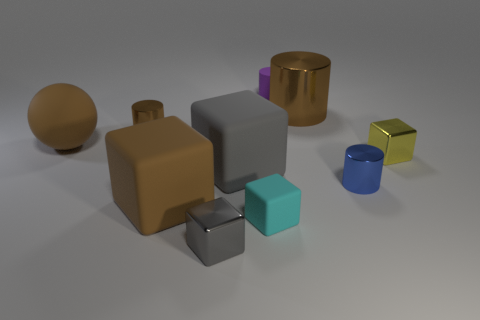What number of other things are made of the same material as the small gray block?
Keep it short and to the point. 4. There is a small rubber block; does it have the same color as the metal block to the right of the tiny gray shiny object?
Your answer should be very brief. No. Are there more big brown rubber balls that are on the left side of the matte cylinder than brown metallic cubes?
Ensure brevity in your answer.  Yes. There is a tiny shiny cylinder behind the tiny shiny cylinder that is in front of the ball; what number of small metal objects are to the left of it?
Offer a terse response. 0. Does the small object that is in front of the small cyan block have the same shape as the cyan thing?
Make the answer very short. Yes. There is a small gray cube in front of the tiny yellow metallic thing; what is it made of?
Your response must be concise. Metal. There is a shiny thing that is both in front of the brown ball and on the left side of the blue metal cylinder; what shape is it?
Offer a very short reply. Cube. What is the material of the yellow block?
Your answer should be very brief. Metal. How many blocks are tiny purple objects or small cyan matte objects?
Make the answer very short. 1. Do the cyan thing and the large brown cylinder have the same material?
Provide a short and direct response. No. 